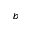Convert formula to latex. <formula><loc_0><loc_0><loc_500><loc_500>_ { b }</formula> 